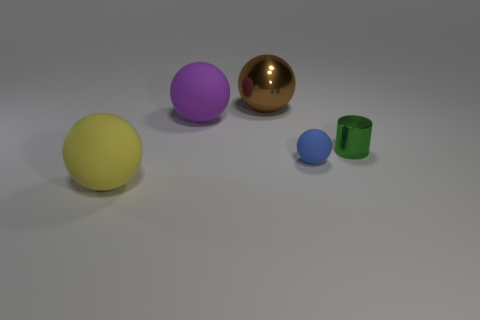Subtract all metallic balls. How many balls are left? 3 Add 3 tiny green cylinders. How many objects exist? 8 Subtract all blue balls. How many balls are left? 3 Subtract all spheres. How many objects are left? 1 Subtract 1 cylinders. How many cylinders are left? 0 Subtract 1 brown balls. How many objects are left? 4 Subtract all purple spheres. Subtract all red cylinders. How many spheres are left? 3 Subtract all metal balls. Subtract all green metal objects. How many objects are left? 3 Add 4 purple balls. How many purple balls are left? 5 Add 5 large balls. How many large balls exist? 8 